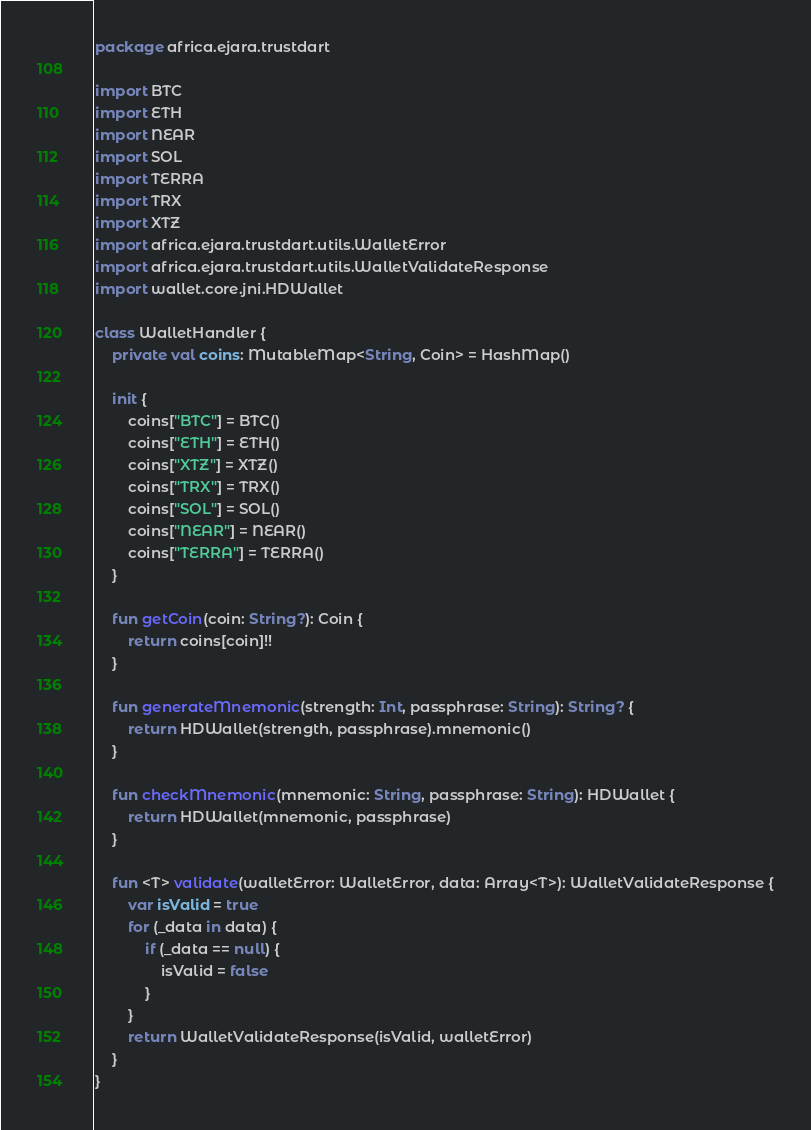Convert code to text. <code><loc_0><loc_0><loc_500><loc_500><_Kotlin_>package africa.ejara.trustdart

import BTC
import ETH
import NEAR
import SOL
import TERRA
import TRX
import XTZ
import africa.ejara.trustdart.utils.WalletError
import africa.ejara.trustdart.utils.WalletValidateResponse
import wallet.core.jni.HDWallet

class WalletHandler {
    private val coins: MutableMap<String, Coin> = HashMap()

    init {
        coins["BTC"] = BTC()
        coins["ETH"] = ETH()
        coins["XTZ"] = XTZ()
        coins["TRX"] = TRX()
        coins["SOL"] = SOL()
        coins["NEAR"] = NEAR()
        coins["TERRA"] = TERRA()
    }

    fun getCoin(coin: String?): Coin {
        return coins[coin]!!
    }

    fun generateMnemonic(strength: Int, passphrase: String): String? {
        return HDWallet(strength, passphrase).mnemonic()
    }

    fun checkMnemonic(mnemonic: String, passphrase: String): HDWallet {
        return HDWallet(mnemonic, passphrase)
    }

    fun <T> validate(walletError: WalletError, data: Array<T>): WalletValidateResponse {
        var isValid = true
        for (_data in data) {
            if (_data == null) {
                isValid = false
            }
        }
        return WalletValidateResponse(isValid, walletError)
    }
}
</code> 